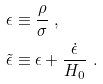<formula> <loc_0><loc_0><loc_500><loc_500>\epsilon & \equiv \frac { \rho } { \sigma } \ , \\ \tilde { \epsilon } & \equiv \epsilon + \frac { \dot { \epsilon } } { H _ { 0 } } \ .</formula> 